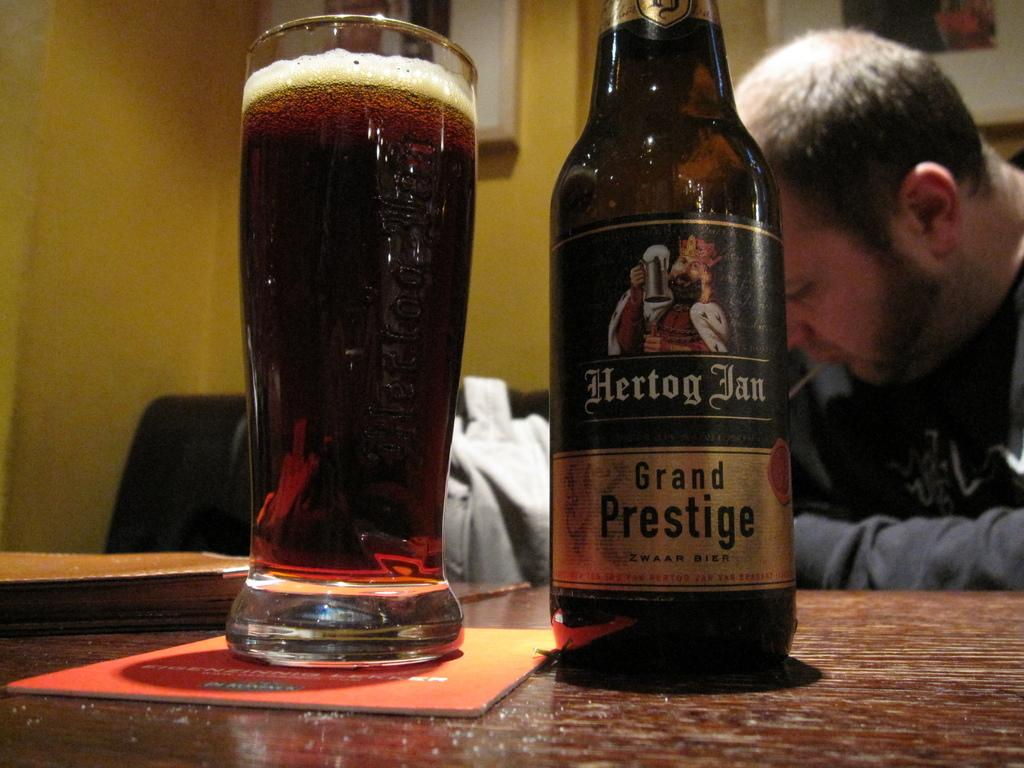Provide a one-sentence caption for the provided image. a bottle of Hertog Ian Grand Prestige by a glass. 